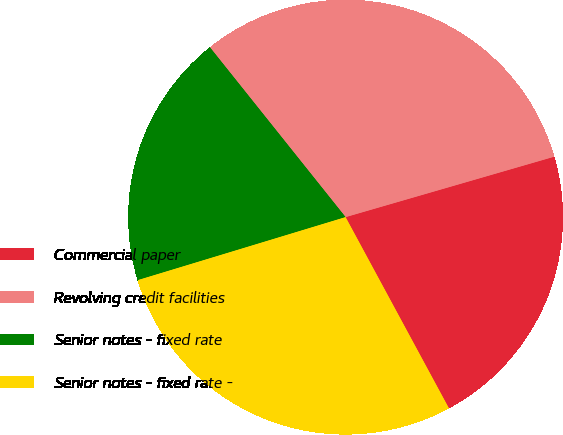Convert chart. <chart><loc_0><loc_0><loc_500><loc_500><pie_chart><fcel>Commercial paper<fcel>Revolving credit facilities<fcel>Senior notes - fixed rate<fcel>Senior notes - fixed rate -<nl><fcel>21.6%<fcel>31.24%<fcel>18.96%<fcel>28.2%<nl></chart> 